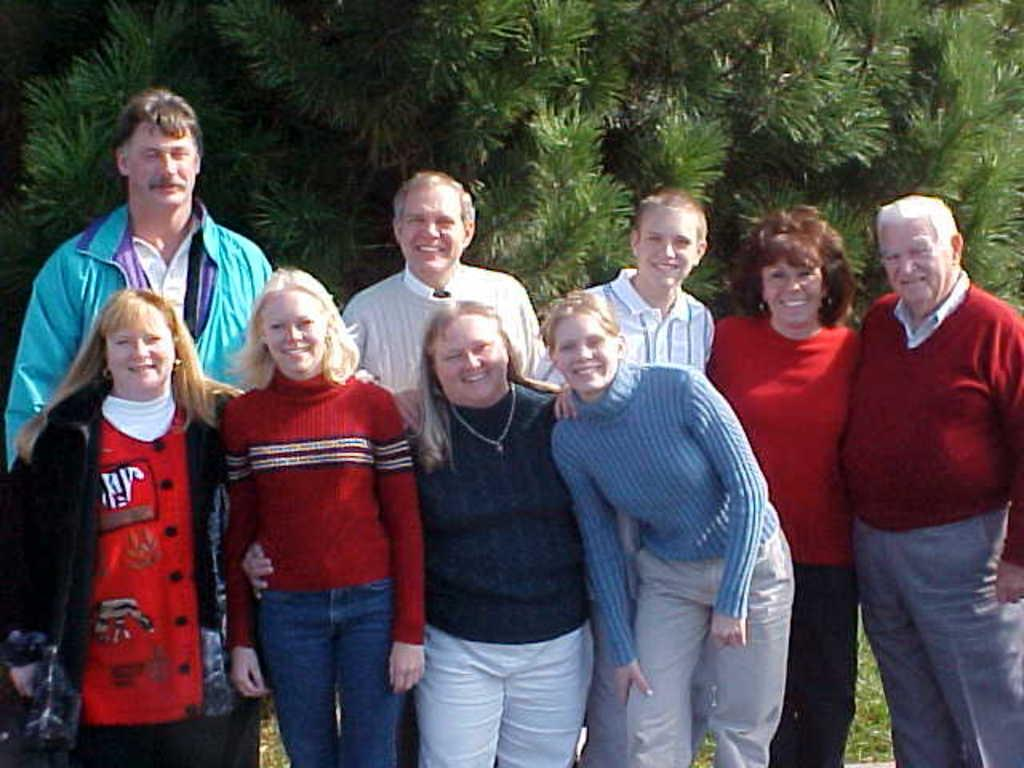How many girls are in the image? There are 4 girls standing and smiling in the image. How many people are standing and smiling in total? There are 5 persons standing and smiling behind the girls, making a total of 9 people (4 girls + 5 persons). What can be seen in the background of the image? There are trees visible in the background of the image. What type of board can be seen bursting into flames in the image? There is no board or flames present in the image; it features 4 girls and 5 persons standing and smiling, with trees visible in the background of the image? 